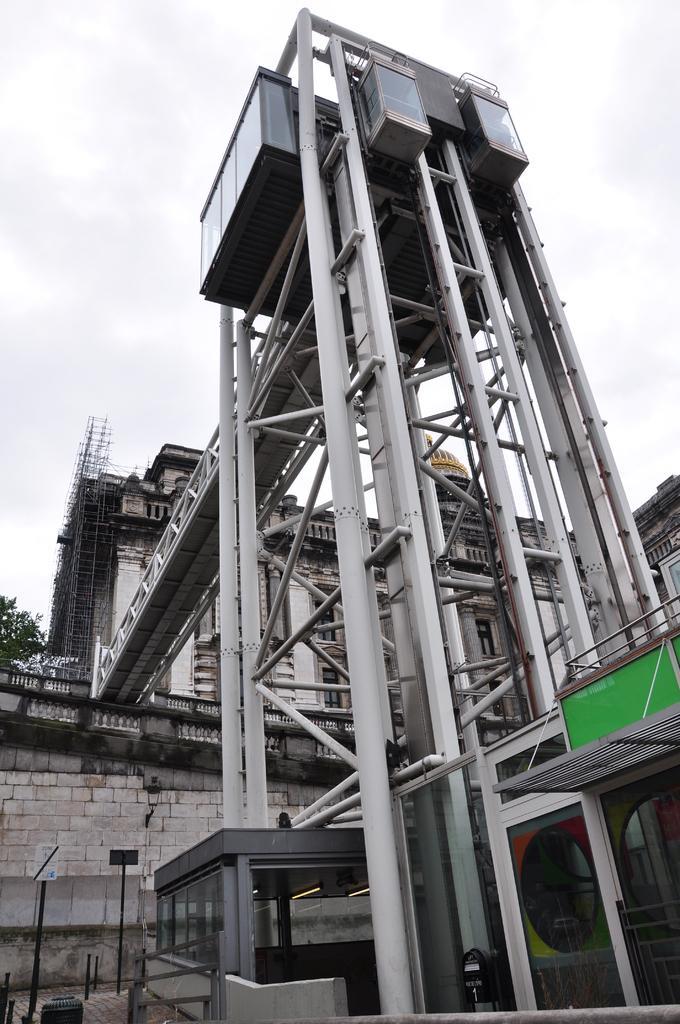Describe this image in one or two sentences. This picture is clicked outside. In the foreground we can see an architecture and the metal rods. In the center we can see a bridge. In the background we can see the sky, building, tree and a dome and some objects. In the bottom left corner we can see the ground and the poles and some other objects. 